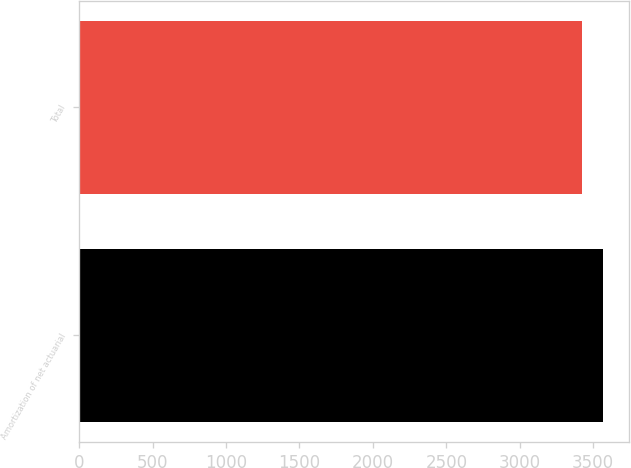Convert chart to OTSL. <chart><loc_0><loc_0><loc_500><loc_500><bar_chart><fcel>Amortization of net actuarial<fcel>Total<nl><fcel>3568<fcel>3422<nl></chart> 